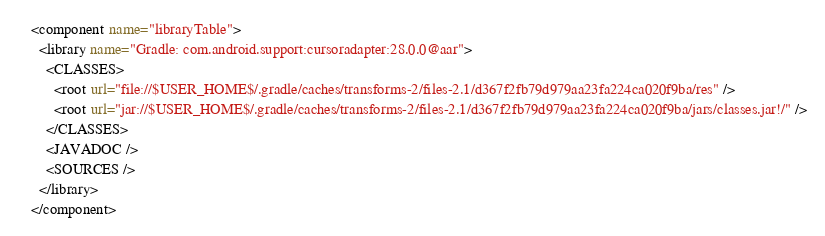Convert code to text. <code><loc_0><loc_0><loc_500><loc_500><_XML_><component name="libraryTable">
  <library name="Gradle: com.android.support:cursoradapter:28.0.0@aar">
    <CLASSES>
      <root url="file://$USER_HOME$/.gradle/caches/transforms-2/files-2.1/d367f2fb79d979aa23fa224ca020f9ba/res" />
      <root url="jar://$USER_HOME$/.gradle/caches/transforms-2/files-2.1/d367f2fb79d979aa23fa224ca020f9ba/jars/classes.jar!/" />
    </CLASSES>
    <JAVADOC />
    <SOURCES />
  </library>
</component></code> 